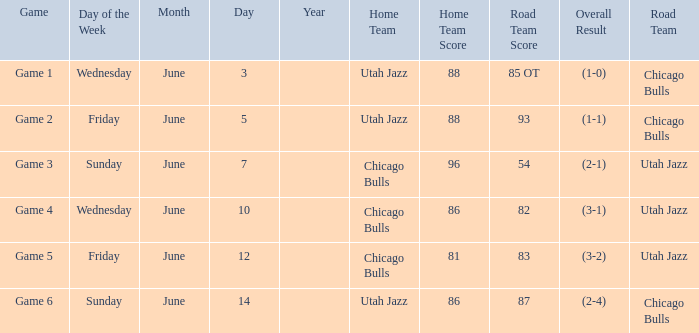Result of 86-87 (2-4) is what game? Game 6. 